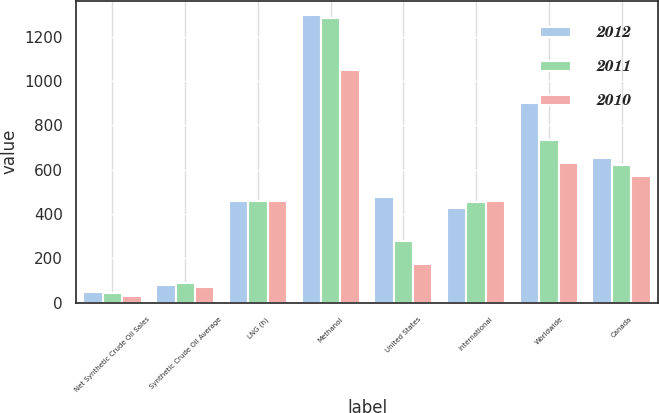Convert chart. <chart><loc_0><loc_0><loc_500><loc_500><stacked_bar_chart><ecel><fcel>Net Synthetic Crude Oil Sales<fcel>Synthetic Crude Oil Average<fcel>LNG (h)<fcel>Methanol<fcel>United States<fcel>International<fcel>Worldwide<fcel>Canada<nl><fcel>2012<fcel>47<fcel>81.72<fcel>457<fcel>1298<fcel>475<fcel>426<fcel>901<fcel>653<nl><fcel>2011<fcel>43<fcel>91.65<fcel>457<fcel>1282<fcel>279<fcel>454<fcel>733<fcel>623<nl><fcel>2010<fcel>29<fcel>71.06<fcel>457<fcel>1049<fcel>173<fcel>457<fcel>630<fcel>572<nl></chart> 